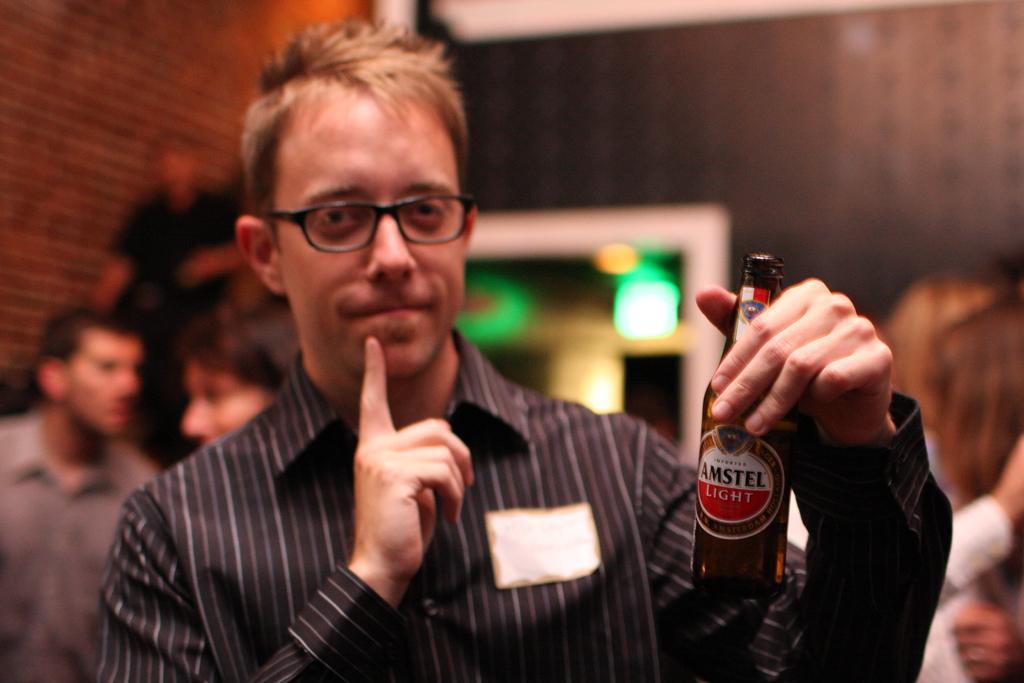Can you describe this image briefly? In the image we can see there is a man who is standing and he is holding a wine bottle in his hand. At the back there are people standing and the image is blur. 